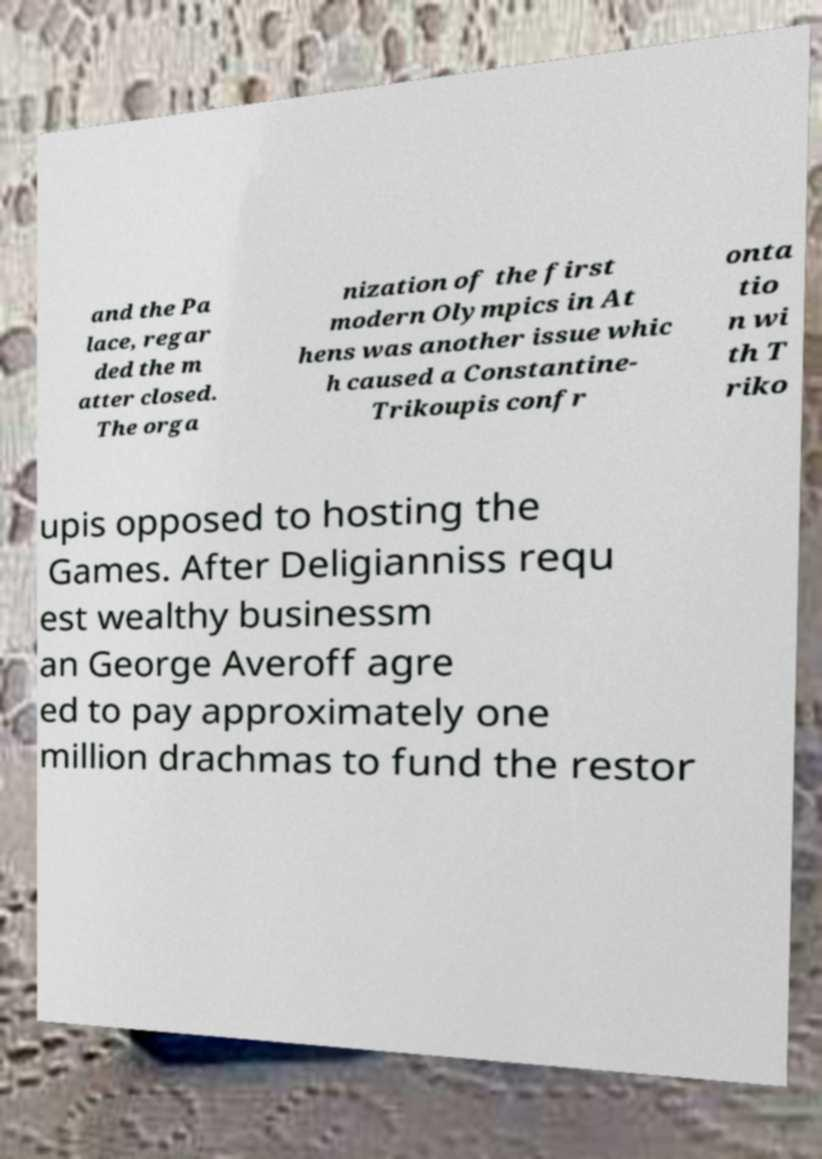Please identify and transcribe the text found in this image. and the Pa lace, regar ded the m atter closed. The orga nization of the first modern Olympics in At hens was another issue whic h caused a Constantine- Trikoupis confr onta tio n wi th T riko upis opposed to hosting the Games. After Deligianniss requ est wealthy businessm an George Averoff agre ed to pay approximately one million drachmas to fund the restor 